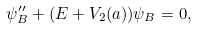<formula> <loc_0><loc_0><loc_500><loc_500>\psi _ { B } ^ { \prime \prime } + ( E + V _ { 2 } ( a ) ) \psi _ { B } = 0 ,</formula> 